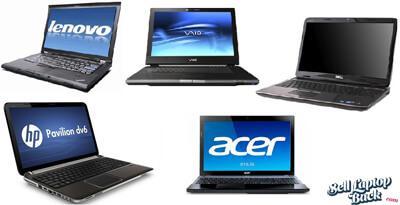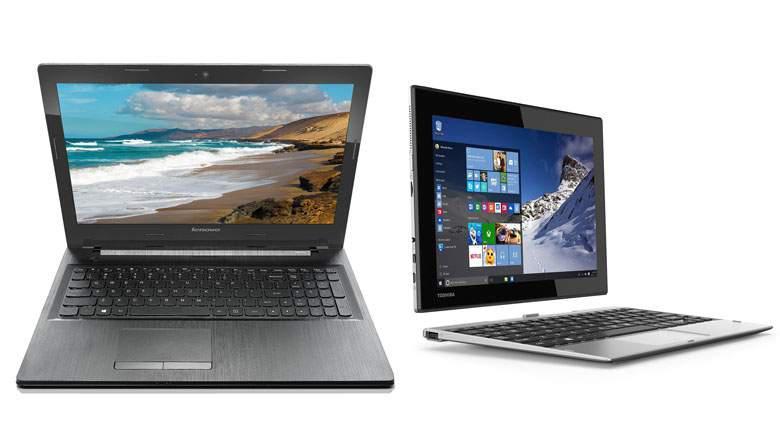The first image is the image on the left, the second image is the image on the right. For the images displayed, is the sentence "Right image shows more devices with screens than left image." factually correct? Answer yes or no. No. The first image is the image on the left, the second image is the image on the right. Evaluate the accuracy of this statement regarding the images: "The right image contains three or more computers.". Is it true? Answer yes or no. No. 